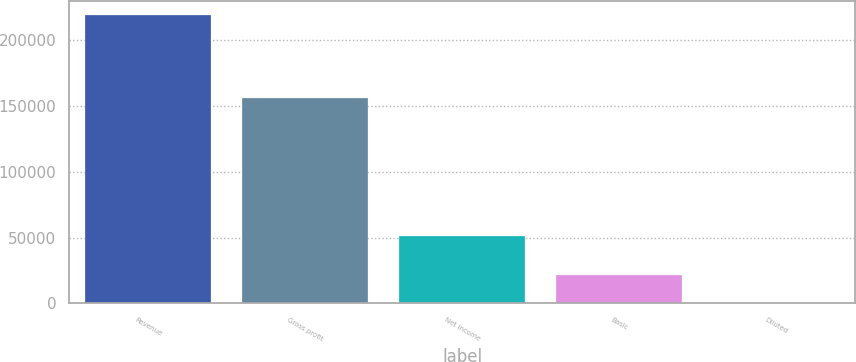<chart> <loc_0><loc_0><loc_500><loc_500><bar_chart><fcel>Revenue<fcel>Gross profit<fcel>Net income<fcel>Basic<fcel>Diluted<nl><fcel>219189<fcel>156056<fcel>51182<fcel>21920<fcel>1.28<nl></chart> 